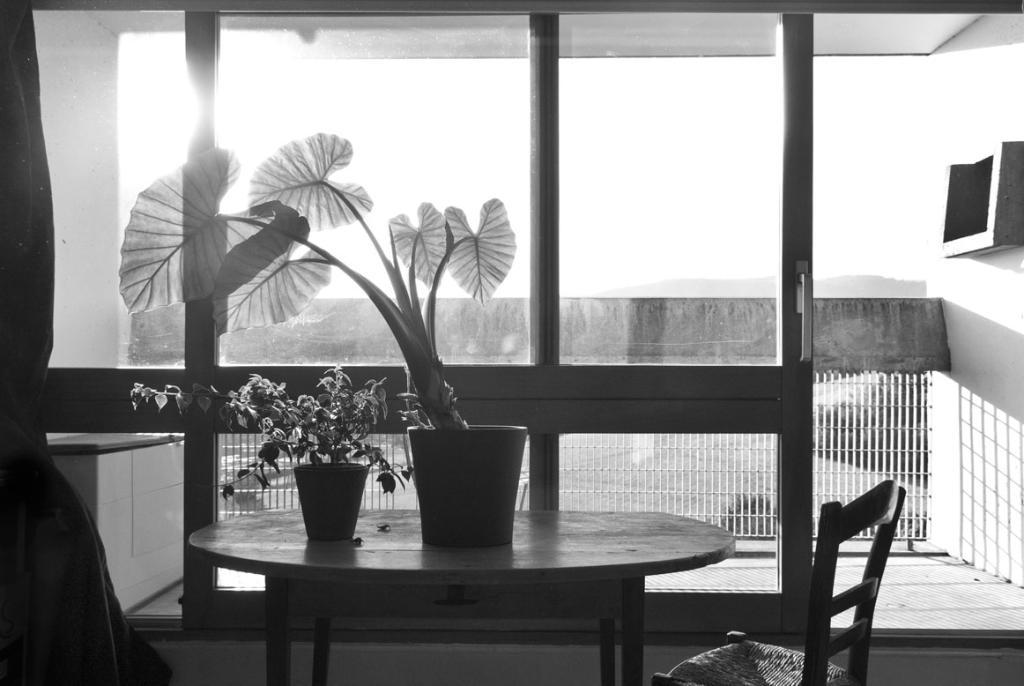What is placed on the table in the image? There are plants on the table in the image. What type of furniture is present in the image? There is a chair in the image. What can be seen in the background of the image? There is railing and a glass door visible in the background of the image. What is the color scheme of the image? The image is in black and white. What type of bean is being cooked in the pan in the image? There is no pan or bean present in the image. How many arms are visible in the image? There are no arms visible in the image. 